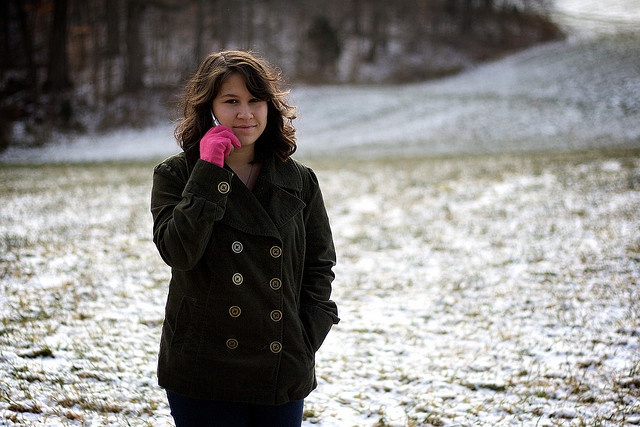Describe the objects in this image and their specific colors. I can see people in black, maroon, and brown tones, cell phone in black, gray, and white tones, and cell phone in black, maroon, and gray tones in this image. 